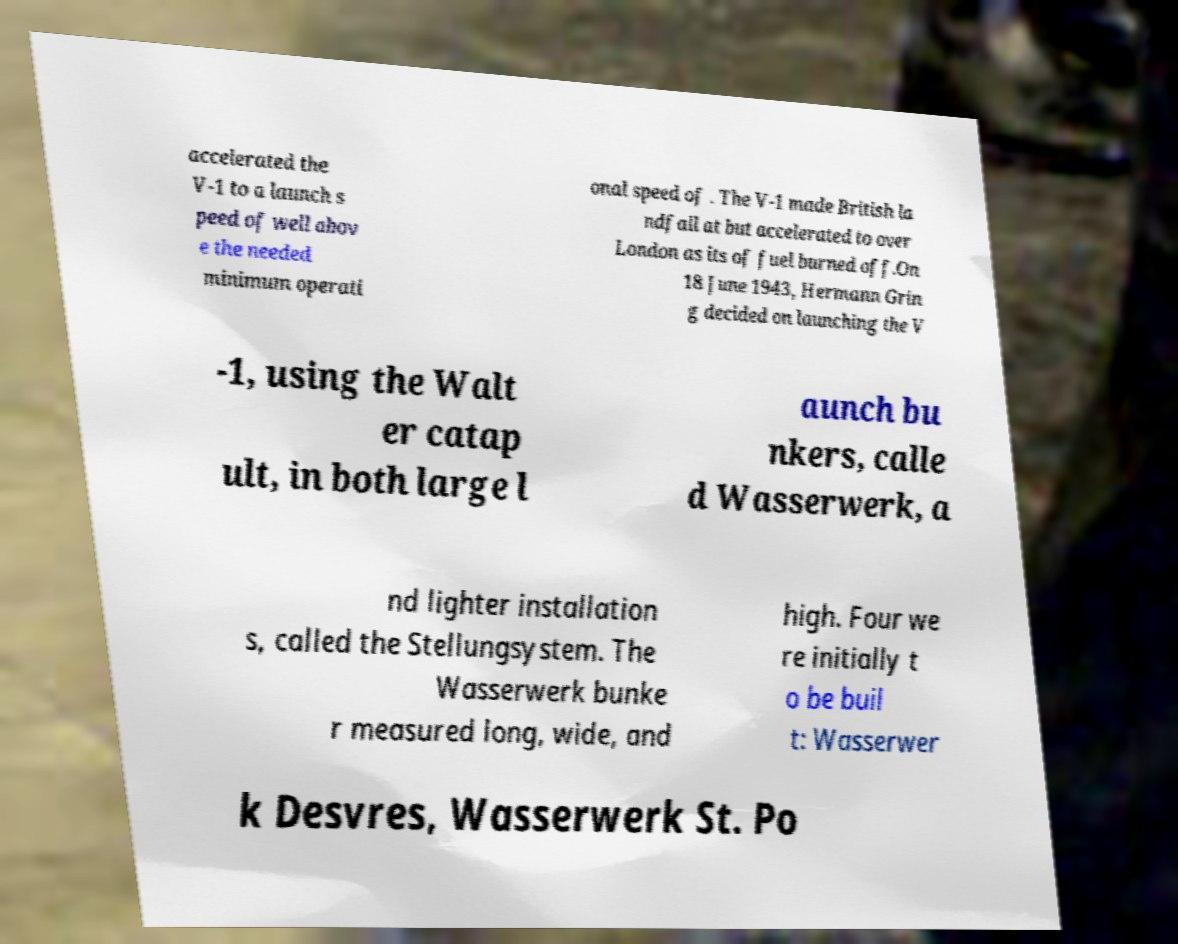Could you assist in decoding the text presented in this image and type it out clearly? accelerated the V-1 to a launch s peed of well abov e the needed minimum operati onal speed of . The V-1 made British la ndfall at but accelerated to over London as its of fuel burned off.On 18 June 1943, Hermann Grin g decided on launching the V -1, using the Walt er catap ult, in both large l aunch bu nkers, calle d Wasserwerk, a nd lighter installation s, called the Stellungsystem. The Wasserwerk bunke r measured long, wide, and high. Four we re initially t o be buil t: Wasserwer k Desvres, Wasserwerk St. Po 